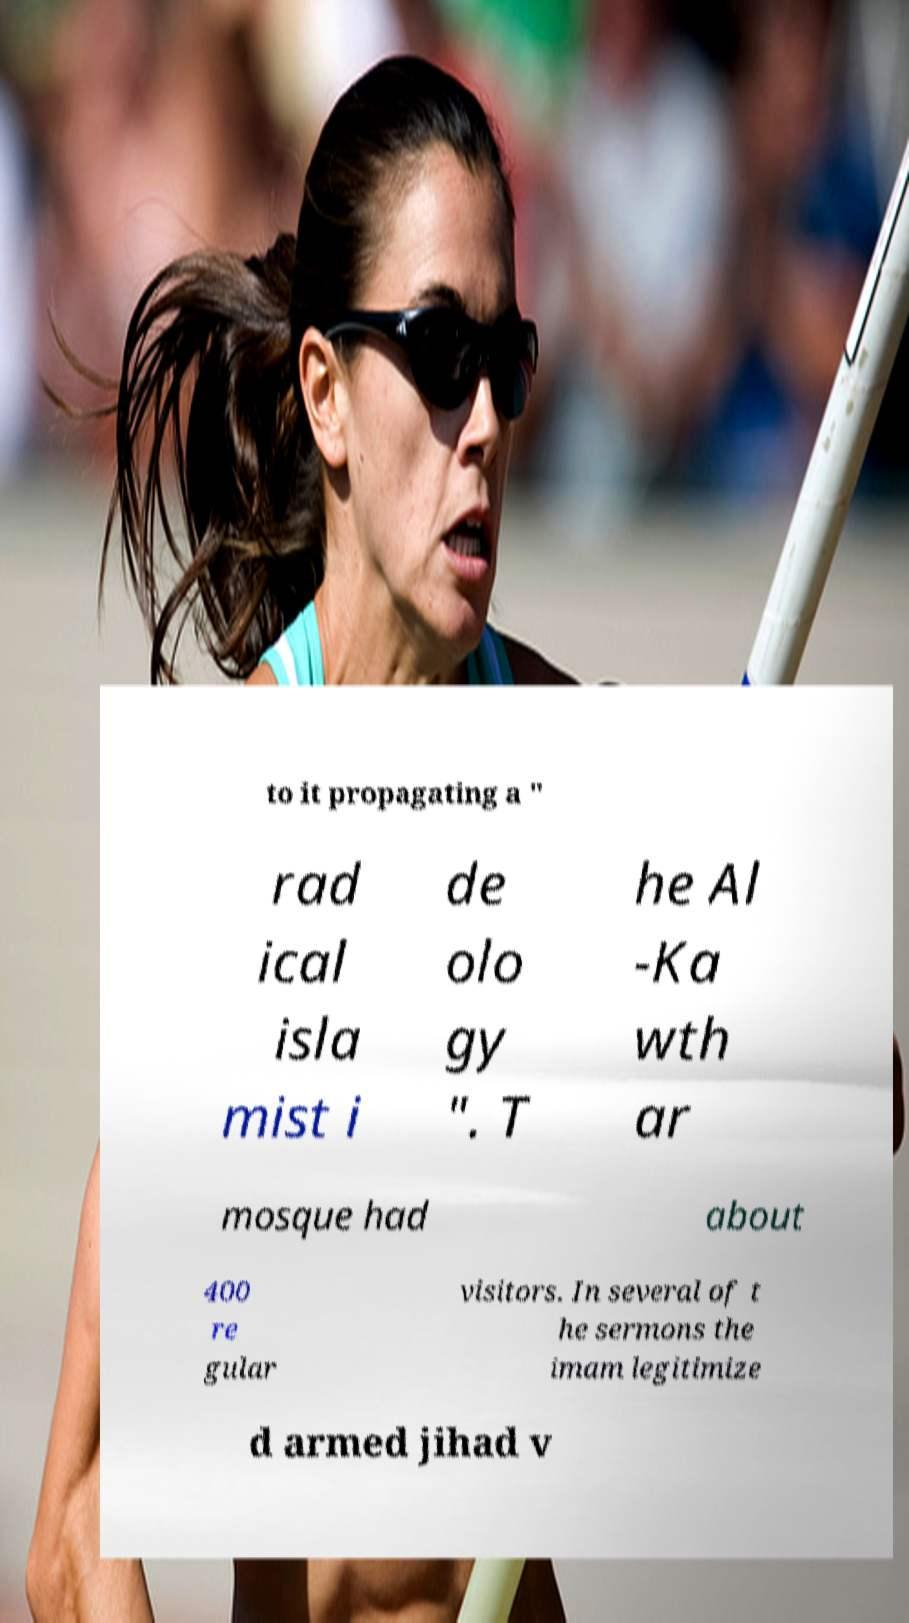Can you read and provide the text displayed in the image?This photo seems to have some interesting text. Can you extract and type it out for me? to it propagating a " rad ical isla mist i de olo gy ". T he Al -Ka wth ar mosque had about 400 re gular visitors. In several of t he sermons the imam legitimize d armed jihad v 